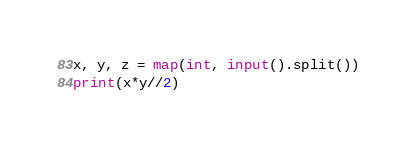<code> <loc_0><loc_0><loc_500><loc_500><_Python_>x, y, z = map(int, input().split())
print(x*y//2)</code> 